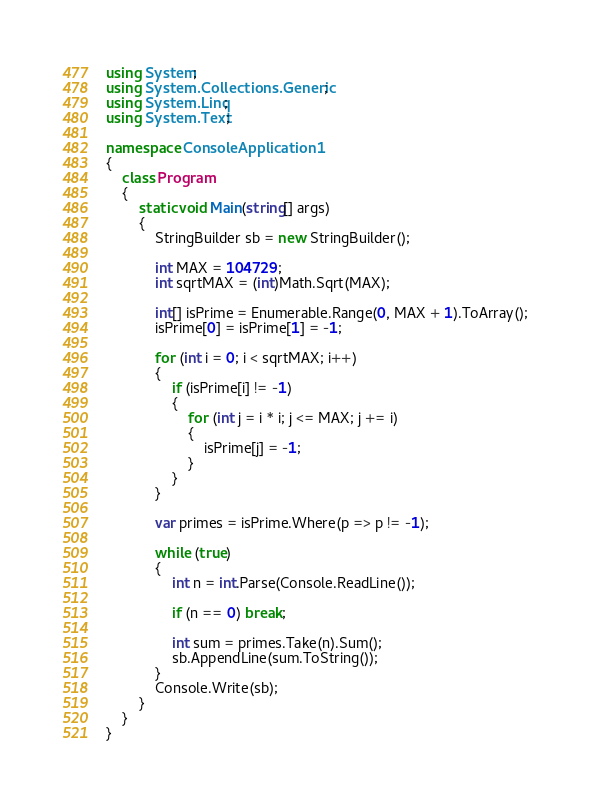Convert code to text. <code><loc_0><loc_0><loc_500><loc_500><_C#_>using System;
using System.Collections.Generic;
using System.Linq;
using System.Text;

namespace ConsoleApplication1
{
    class Program
    {
        static void Main(string[] args)
        {
            StringBuilder sb = new StringBuilder();

            int MAX = 104729;
            int sqrtMAX = (int)Math.Sqrt(MAX);

            int[] isPrime = Enumerable.Range(0, MAX + 1).ToArray();
            isPrime[0] = isPrime[1] = -1;

            for (int i = 0; i < sqrtMAX; i++)
            {
                if (isPrime[i] != -1)
                {
                    for (int j = i * i; j <= MAX; j += i)
                    {
                        isPrime[j] = -1;
                    }
                }
            }

            var primes = isPrime.Where(p => p != -1);

            while (true)
            {
                int n = int.Parse(Console.ReadLine());

                if (n == 0) break;

                int sum = primes.Take(n).Sum();
                sb.AppendLine(sum.ToString());
            }
            Console.Write(sb);
        }
    }
}</code> 